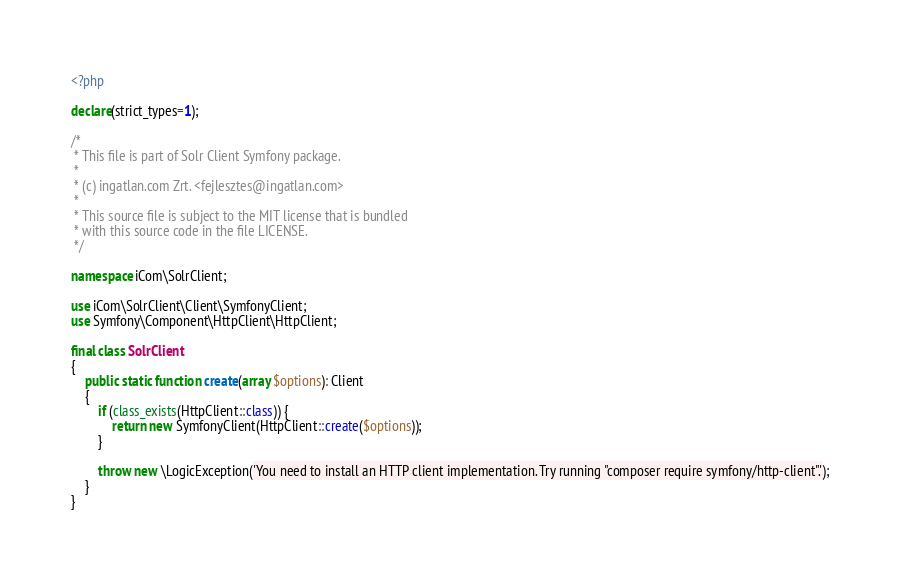<code> <loc_0><loc_0><loc_500><loc_500><_PHP_><?php

declare(strict_types=1);

/*
 * This file is part of Solr Client Symfony package.
 *
 * (c) ingatlan.com Zrt. <fejlesztes@ingatlan.com>
 *
 * This source file is subject to the MIT license that is bundled
 * with this source code in the file LICENSE.
 */

namespace iCom\SolrClient;

use iCom\SolrClient\Client\SymfonyClient;
use Symfony\Component\HttpClient\HttpClient;

final class SolrClient
{
    public static function create(array $options): Client
    {
        if (class_exists(HttpClient::class)) {
            return new SymfonyClient(HttpClient::create($options));
        }

        throw new \LogicException('You need to install an HTTP client implementation. Try running "composer require symfony/http-client".');
    }
}
</code> 